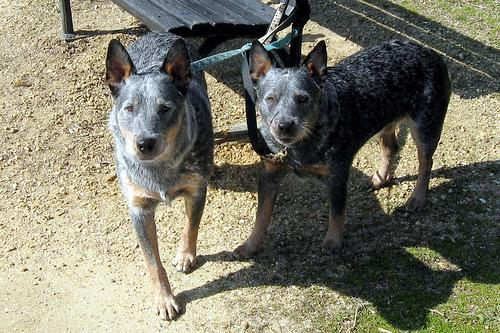What would most likely explain why these dogs look similar? siblings 